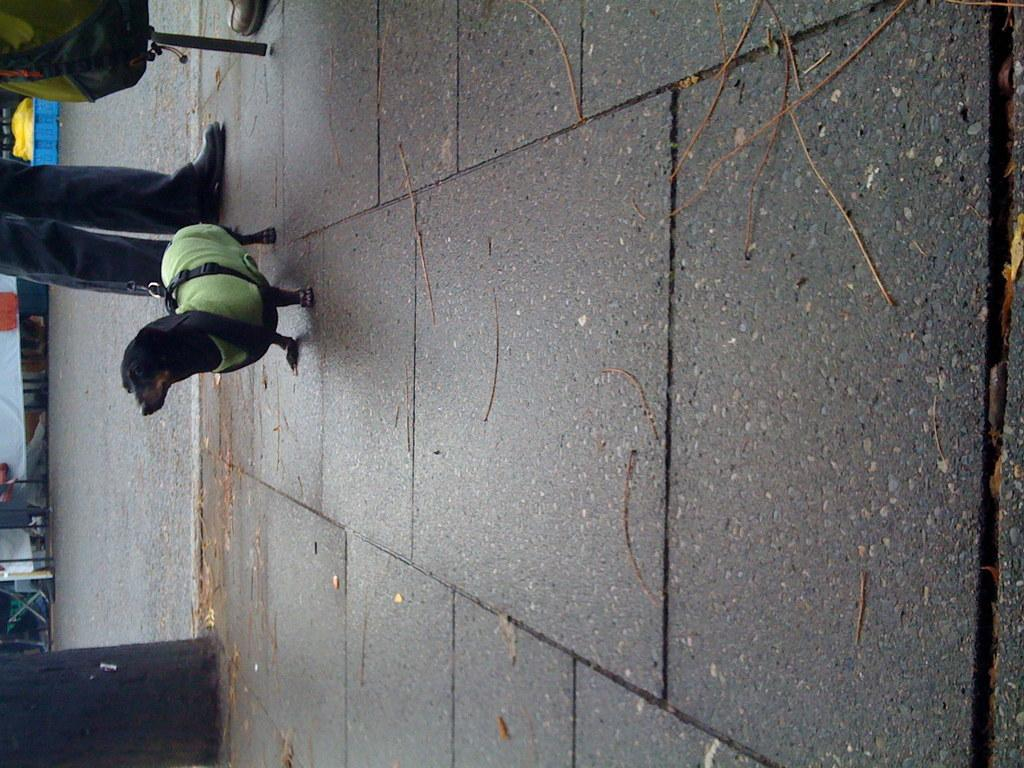What type of animal is in the image? There is a dog in the image. Can you describe any part of a person in the image? Legs of a person are visible in the image. What color is the object on the pavement? There is a black color object on the pavement. What type of bag is in the image? There is a backpack in the image. What is beside the pavement in the image? There is a road beside the pavement in the image. What type of beef is being cooked on the road in the image? There is no beef or cooking activity present in the image. Is there a basketball game happening on the road in the image? There is no basketball game or any reference to a basketball in the image. 